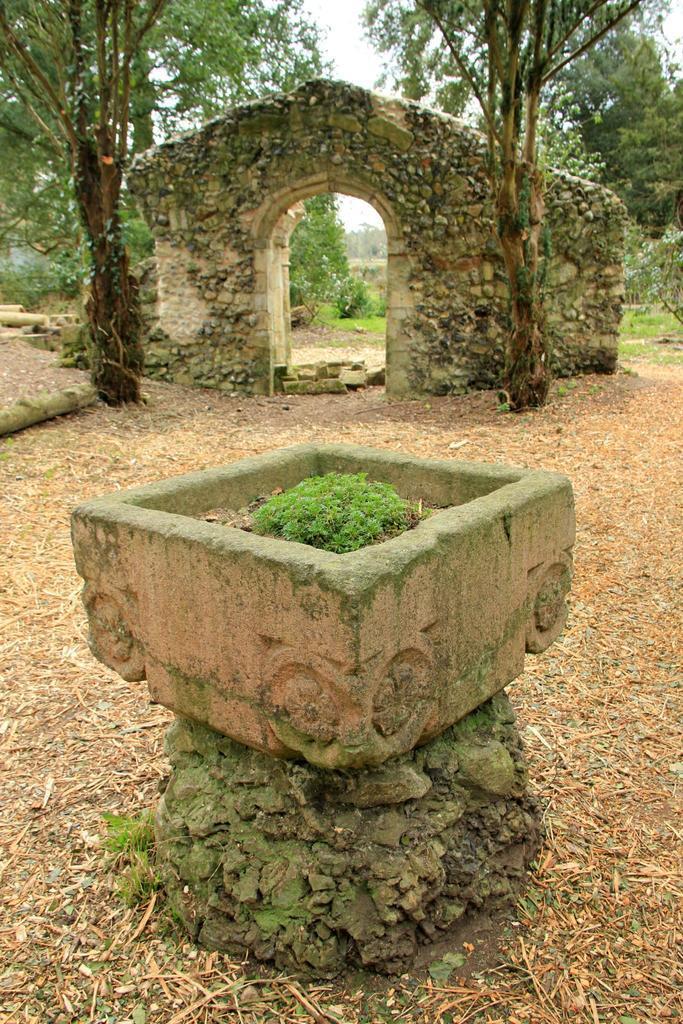Describe this image in one or two sentences. In this picture, it seems to be there is a cement tub in the center of the image and there is an arch and trees in the background area of the image. 